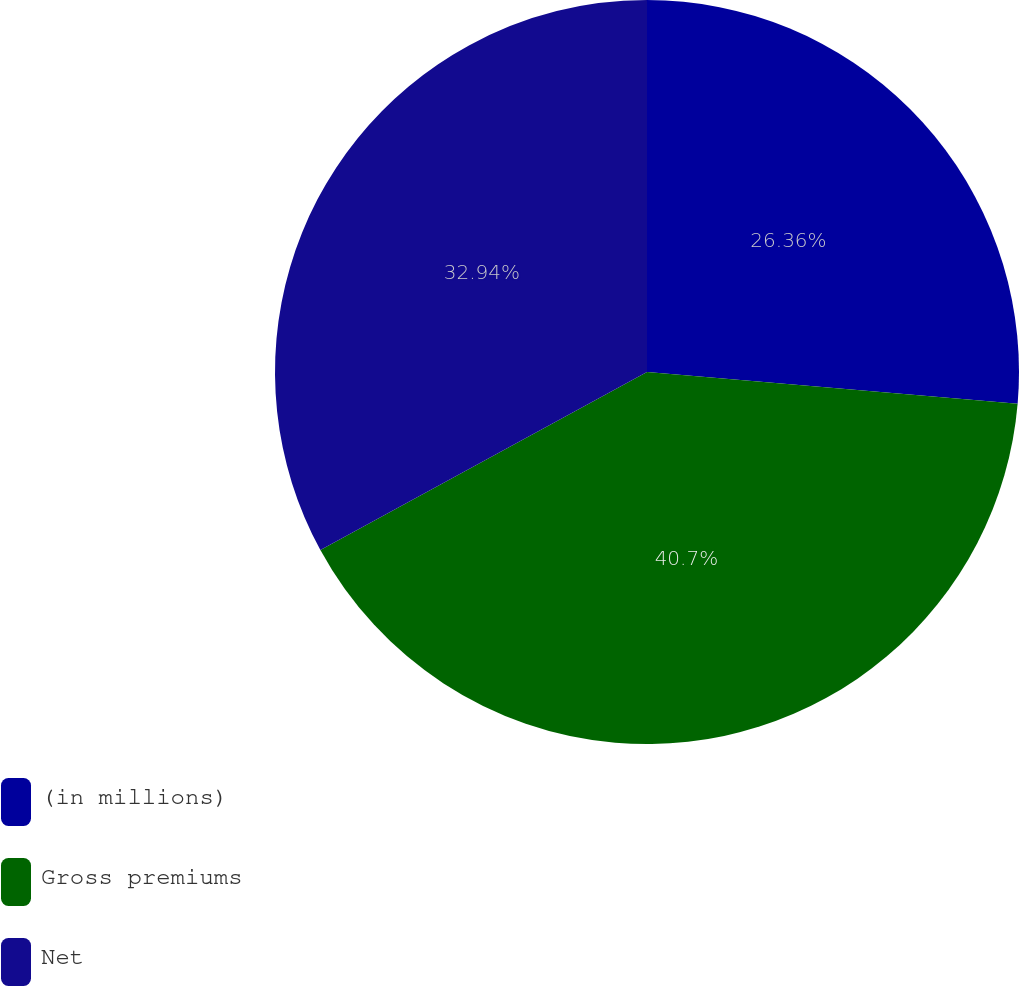Convert chart to OTSL. <chart><loc_0><loc_0><loc_500><loc_500><pie_chart><fcel>(in millions)<fcel>Gross premiums<fcel>Net<nl><fcel>26.36%<fcel>40.69%<fcel>32.94%<nl></chart> 